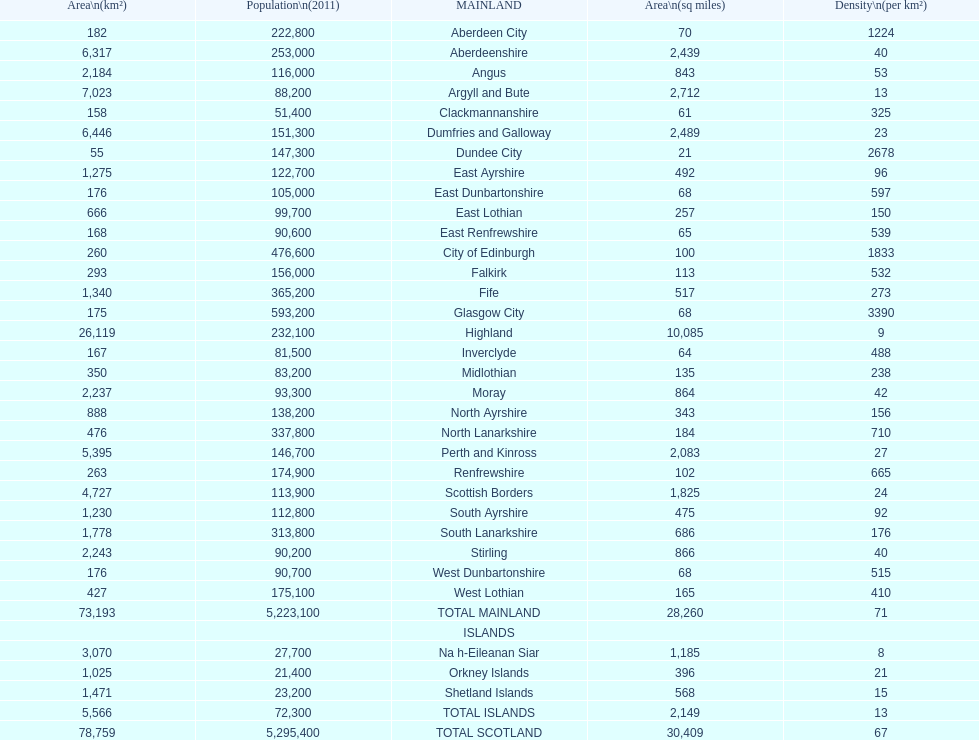What number of mainlands have populations under 100,000? 9. 